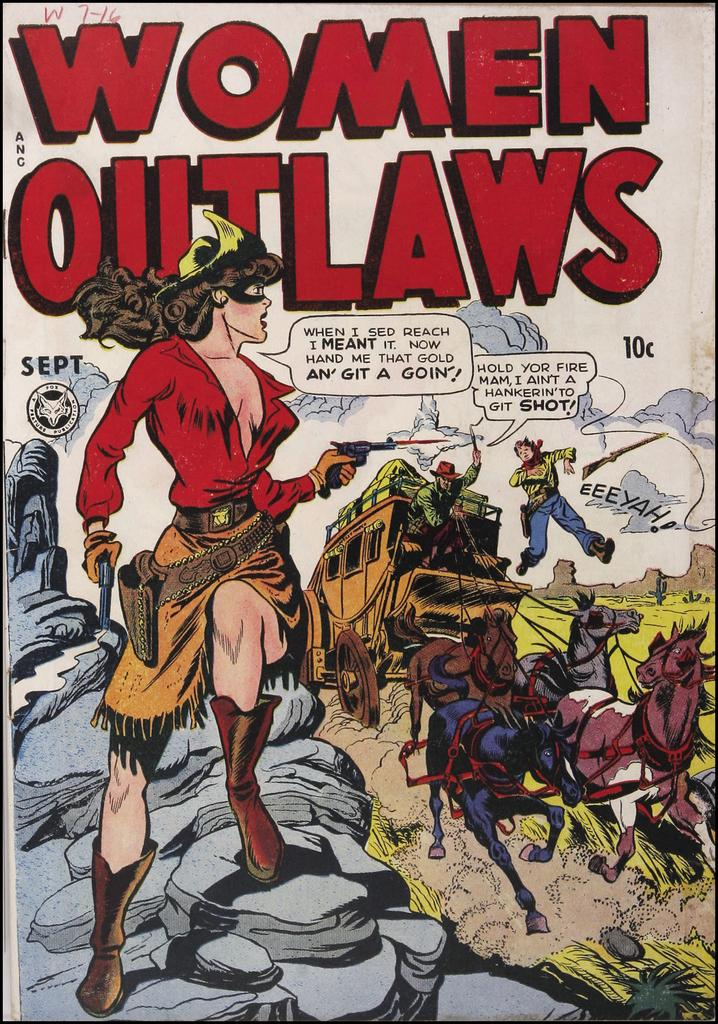<image>
Write a terse but informative summary of the picture. A comic book called Women Outlaws featuring a horse and carriage scene. 